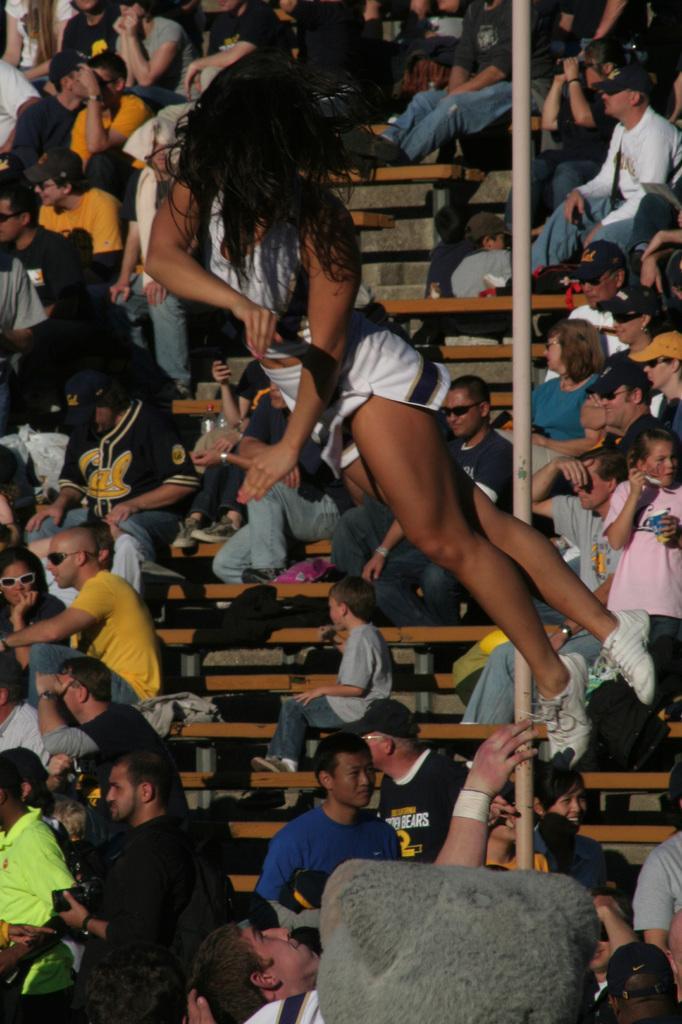Could you give a brief overview of what you see in this image? In this image, a woman in the air. At the bottom and background we can see a group of people. Few people are sitting on the stairs. On the right side of the image, there is a pole we can see. 